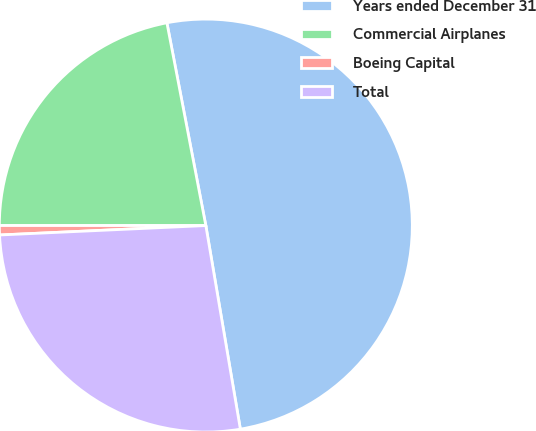Convert chart to OTSL. <chart><loc_0><loc_0><loc_500><loc_500><pie_chart><fcel>Years ended December 31<fcel>Commercial Airplanes<fcel>Boeing Capital<fcel>Total<nl><fcel>50.35%<fcel>21.98%<fcel>0.73%<fcel>26.95%<nl></chart> 